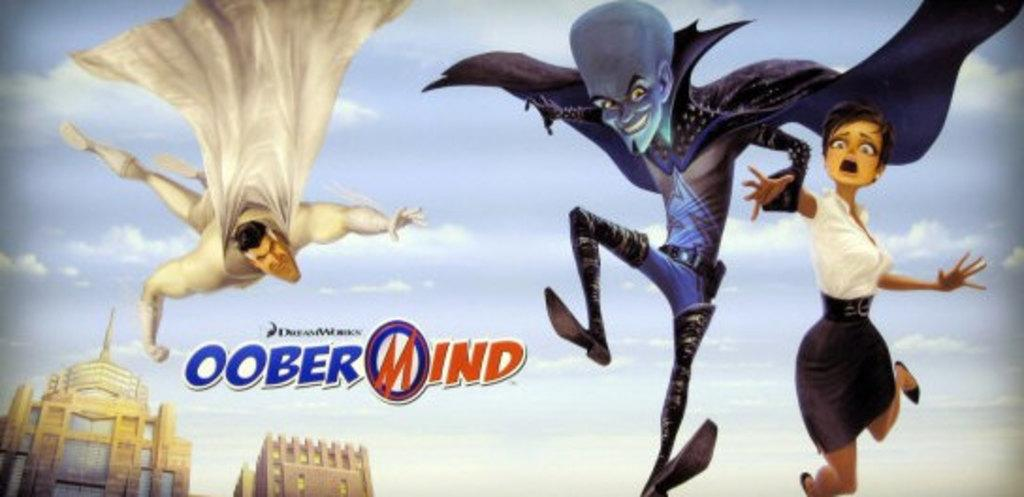Provide a one-sentence caption for the provided image. a poster for a movie that is called oober wind. 